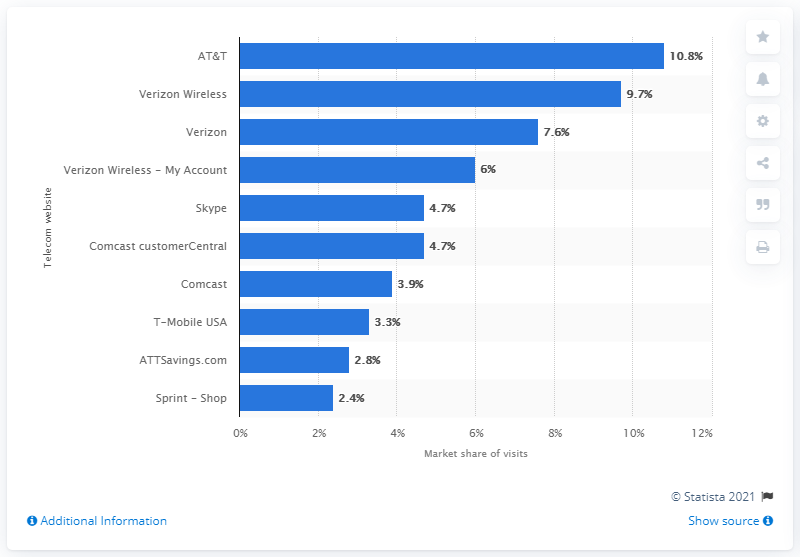Highlight a few significant elements in this photo. Of the total number of site visits conducted by Comcast's customerCentral, 4.7% were made by Comcast customers. Comcast's customerCentral had a market share of 4.7 percent of the total telecommunications site visits. 